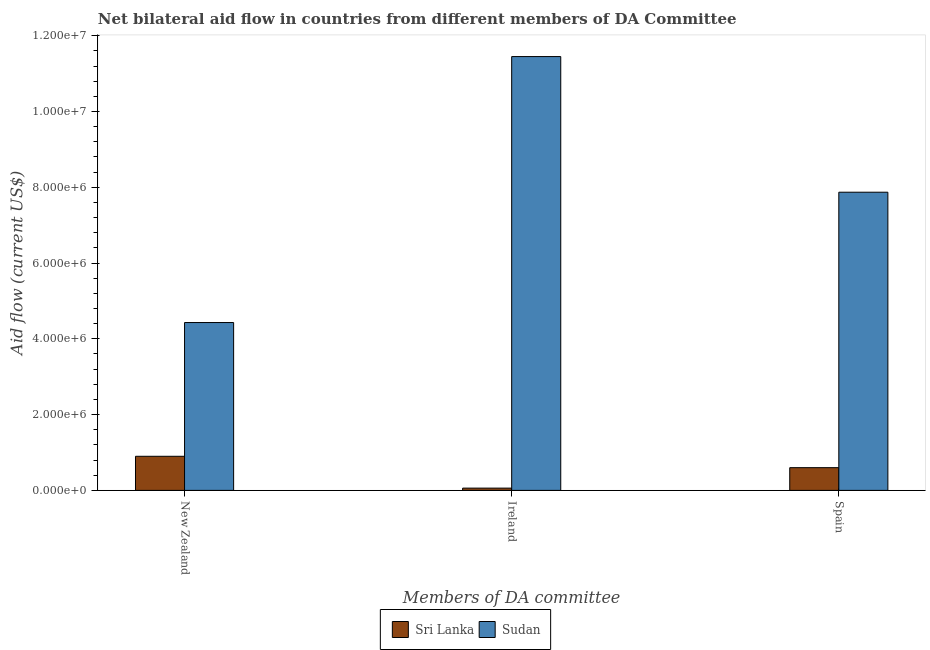How many different coloured bars are there?
Your answer should be very brief. 2. How many groups of bars are there?
Provide a succinct answer. 3. Are the number of bars per tick equal to the number of legend labels?
Keep it short and to the point. Yes. Are the number of bars on each tick of the X-axis equal?
Keep it short and to the point. Yes. How many bars are there on the 1st tick from the left?
Make the answer very short. 2. What is the label of the 3rd group of bars from the left?
Your answer should be compact. Spain. What is the amount of aid provided by ireland in Sudan?
Your response must be concise. 1.14e+07. Across all countries, what is the maximum amount of aid provided by ireland?
Offer a very short reply. 1.14e+07. Across all countries, what is the minimum amount of aid provided by new zealand?
Your response must be concise. 9.00e+05. In which country was the amount of aid provided by new zealand maximum?
Your response must be concise. Sudan. In which country was the amount of aid provided by spain minimum?
Provide a succinct answer. Sri Lanka. What is the total amount of aid provided by spain in the graph?
Your response must be concise. 8.47e+06. What is the difference between the amount of aid provided by ireland in Sudan and that in Sri Lanka?
Ensure brevity in your answer.  1.14e+07. What is the difference between the amount of aid provided by new zealand in Sri Lanka and the amount of aid provided by ireland in Sudan?
Ensure brevity in your answer.  -1.06e+07. What is the average amount of aid provided by ireland per country?
Make the answer very short. 5.76e+06. What is the difference between the amount of aid provided by new zealand and amount of aid provided by ireland in Sri Lanka?
Keep it short and to the point. 8.40e+05. What is the ratio of the amount of aid provided by new zealand in Sudan to that in Sri Lanka?
Make the answer very short. 4.92. Is the amount of aid provided by ireland in Sri Lanka less than that in Sudan?
Offer a very short reply. Yes. What is the difference between the highest and the second highest amount of aid provided by new zealand?
Offer a terse response. 3.53e+06. What is the difference between the highest and the lowest amount of aid provided by spain?
Offer a terse response. 7.27e+06. In how many countries, is the amount of aid provided by ireland greater than the average amount of aid provided by ireland taken over all countries?
Your answer should be very brief. 1. Is the sum of the amount of aid provided by new zealand in Sudan and Sri Lanka greater than the maximum amount of aid provided by spain across all countries?
Ensure brevity in your answer.  No. What does the 2nd bar from the left in New Zealand represents?
Keep it short and to the point. Sudan. What does the 1st bar from the right in Spain represents?
Your answer should be compact. Sudan. How many bars are there?
Make the answer very short. 6. What is the difference between two consecutive major ticks on the Y-axis?
Make the answer very short. 2.00e+06. Are the values on the major ticks of Y-axis written in scientific E-notation?
Provide a short and direct response. Yes. Does the graph contain any zero values?
Make the answer very short. No. Where does the legend appear in the graph?
Offer a very short reply. Bottom center. How many legend labels are there?
Offer a very short reply. 2. How are the legend labels stacked?
Make the answer very short. Horizontal. What is the title of the graph?
Ensure brevity in your answer.  Net bilateral aid flow in countries from different members of DA Committee. What is the label or title of the X-axis?
Ensure brevity in your answer.  Members of DA committee. What is the Aid flow (current US$) in Sri Lanka in New Zealand?
Your answer should be compact. 9.00e+05. What is the Aid flow (current US$) of Sudan in New Zealand?
Your answer should be very brief. 4.43e+06. What is the Aid flow (current US$) in Sudan in Ireland?
Your answer should be compact. 1.14e+07. What is the Aid flow (current US$) in Sudan in Spain?
Offer a very short reply. 7.87e+06. Across all Members of DA committee, what is the maximum Aid flow (current US$) in Sri Lanka?
Make the answer very short. 9.00e+05. Across all Members of DA committee, what is the maximum Aid flow (current US$) of Sudan?
Give a very brief answer. 1.14e+07. Across all Members of DA committee, what is the minimum Aid flow (current US$) of Sri Lanka?
Your answer should be compact. 6.00e+04. Across all Members of DA committee, what is the minimum Aid flow (current US$) in Sudan?
Keep it short and to the point. 4.43e+06. What is the total Aid flow (current US$) in Sri Lanka in the graph?
Your answer should be compact. 1.56e+06. What is the total Aid flow (current US$) of Sudan in the graph?
Give a very brief answer. 2.38e+07. What is the difference between the Aid flow (current US$) in Sri Lanka in New Zealand and that in Ireland?
Your answer should be compact. 8.40e+05. What is the difference between the Aid flow (current US$) in Sudan in New Zealand and that in Ireland?
Your response must be concise. -7.02e+06. What is the difference between the Aid flow (current US$) of Sri Lanka in New Zealand and that in Spain?
Your response must be concise. 3.00e+05. What is the difference between the Aid flow (current US$) in Sudan in New Zealand and that in Spain?
Your answer should be very brief. -3.44e+06. What is the difference between the Aid flow (current US$) of Sri Lanka in Ireland and that in Spain?
Make the answer very short. -5.40e+05. What is the difference between the Aid flow (current US$) of Sudan in Ireland and that in Spain?
Ensure brevity in your answer.  3.58e+06. What is the difference between the Aid flow (current US$) of Sri Lanka in New Zealand and the Aid flow (current US$) of Sudan in Ireland?
Give a very brief answer. -1.06e+07. What is the difference between the Aid flow (current US$) of Sri Lanka in New Zealand and the Aid flow (current US$) of Sudan in Spain?
Your response must be concise. -6.97e+06. What is the difference between the Aid flow (current US$) of Sri Lanka in Ireland and the Aid flow (current US$) of Sudan in Spain?
Your response must be concise. -7.81e+06. What is the average Aid flow (current US$) in Sri Lanka per Members of DA committee?
Give a very brief answer. 5.20e+05. What is the average Aid flow (current US$) in Sudan per Members of DA committee?
Provide a short and direct response. 7.92e+06. What is the difference between the Aid flow (current US$) in Sri Lanka and Aid flow (current US$) in Sudan in New Zealand?
Make the answer very short. -3.53e+06. What is the difference between the Aid flow (current US$) in Sri Lanka and Aid flow (current US$) in Sudan in Ireland?
Give a very brief answer. -1.14e+07. What is the difference between the Aid flow (current US$) in Sri Lanka and Aid flow (current US$) in Sudan in Spain?
Ensure brevity in your answer.  -7.27e+06. What is the ratio of the Aid flow (current US$) of Sudan in New Zealand to that in Ireland?
Ensure brevity in your answer.  0.39. What is the ratio of the Aid flow (current US$) in Sri Lanka in New Zealand to that in Spain?
Give a very brief answer. 1.5. What is the ratio of the Aid flow (current US$) of Sudan in New Zealand to that in Spain?
Give a very brief answer. 0.56. What is the ratio of the Aid flow (current US$) of Sri Lanka in Ireland to that in Spain?
Offer a terse response. 0.1. What is the ratio of the Aid flow (current US$) of Sudan in Ireland to that in Spain?
Your answer should be compact. 1.45. What is the difference between the highest and the second highest Aid flow (current US$) in Sudan?
Make the answer very short. 3.58e+06. What is the difference between the highest and the lowest Aid flow (current US$) in Sri Lanka?
Keep it short and to the point. 8.40e+05. What is the difference between the highest and the lowest Aid flow (current US$) in Sudan?
Make the answer very short. 7.02e+06. 